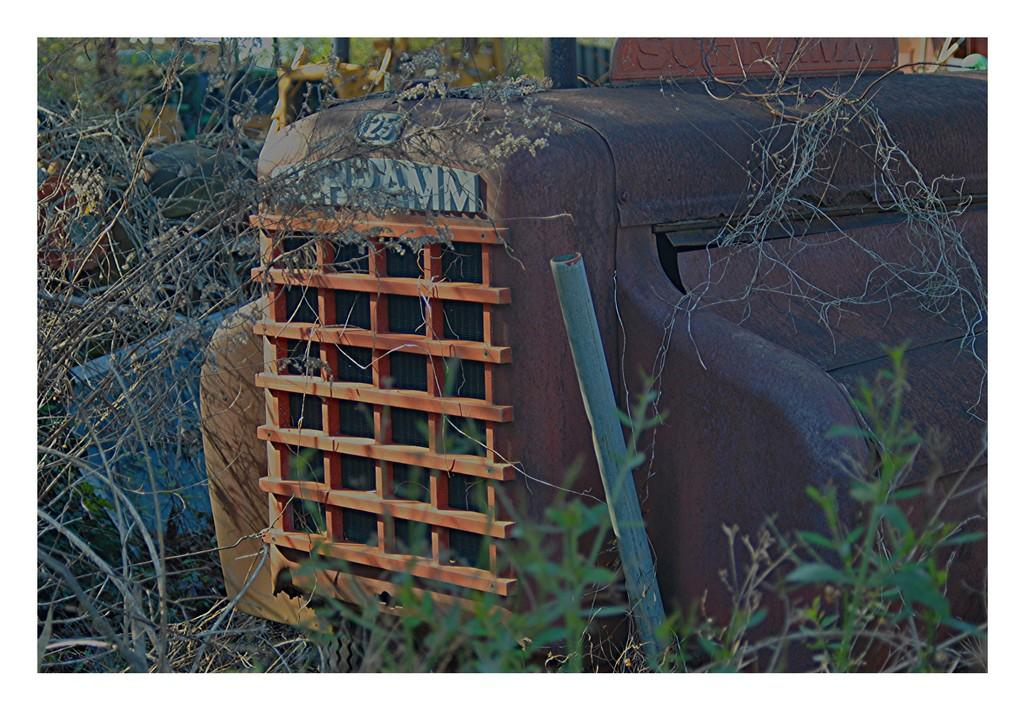What type of living organisms can be seen in the image? Plants can be seen in the image. What material are some of the objects made of in the image? There are metal objects in the image. How many houses are visible in the image? There are no houses visible in the image; it only contains plants and metal objects. 